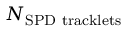<formula> <loc_0><loc_0><loc_500><loc_500>N _ { S P D t r a c k l e t s }</formula> 